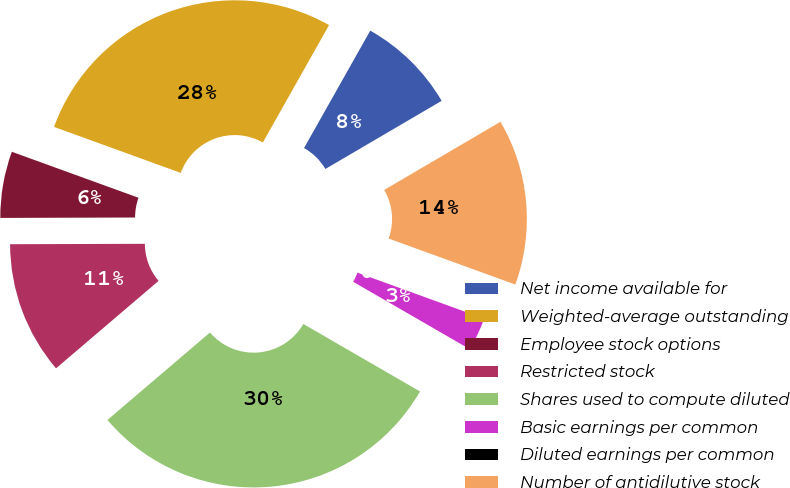Convert chart. <chart><loc_0><loc_0><loc_500><loc_500><pie_chart><fcel>Net income available for<fcel>Weighted-average outstanding<fcel>Employee stock options<fcel>Restricted stock<fcel>Shares used to compute diluted<fcel>Basic earnings per common<fcel>Diluted earnings per common<fcel>Number of antidilutive stock<nl><fcel>8.39%<fcel>27.63%<fcel>5.59%<fcel>11.19%<fcel>30.42%<fcel>2.8%<fcel>0.0%<fcel>13.98%<nl></chart> 